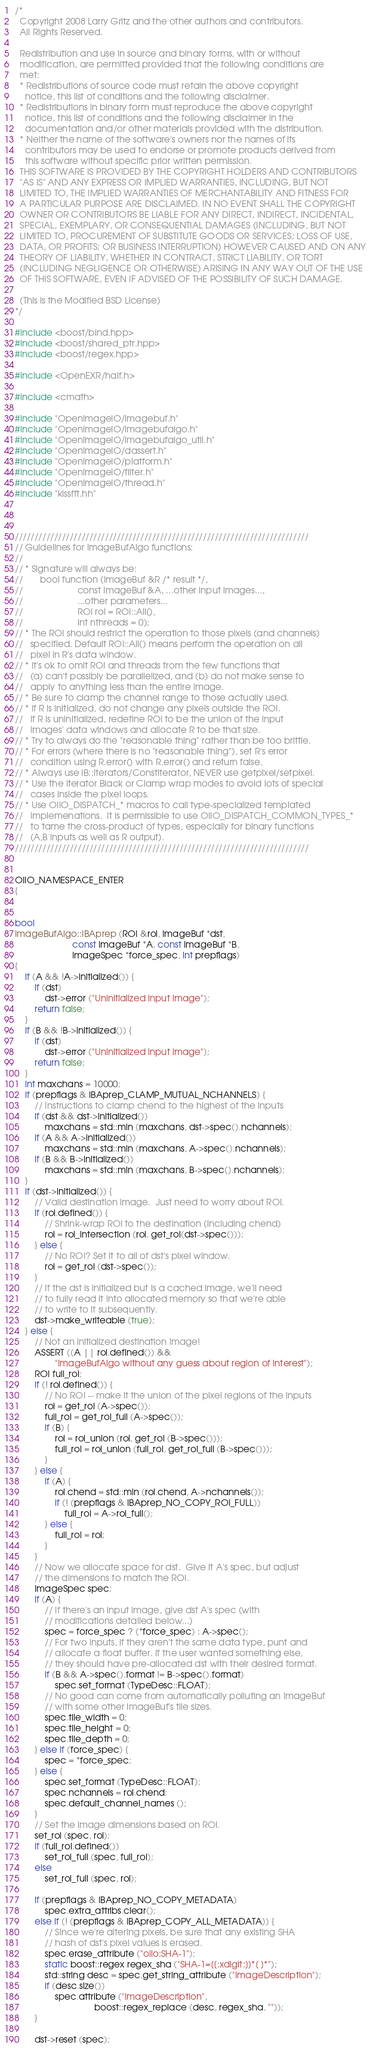Convert code to text. <code><loc_0><loc_0><loc_500><loc_500><_C++_>/*
  Copyright 2008 Larry Gritz and the other authors and contributors.
  All Rights Reserved.

  Redistribution and use in source and binary forms, with or without
  modification, are permitted provided that the following conditions are
  met:
  * Redistributions of source code must retain the above copyright
    notice, this list of conditions and the following disclaimer.
  * Redistributions in binary form must reproduce the above copyright
    notice, this list of conditions and the following disclaimer in the
    documentation and/or other materials provided with the distribution.
  * Neither the name of the software's owners nor the names of its
    contributors may be used to endorse or promote products derived from
    this software without specific prior written permission.
  THIS SOFTWARE IS PROVIDED BY THE COPYRIGHT HOLDERS AND CONTRIBUTORS
  "AS IS" AND ANY EXPRESS OR IMPLIED WARRANTIES, INCLUDING, BUT NOT
  LIMITED TO, THE IMPLIED WARRANTIES OF MERCHANTABILITY AND FITNESS FOR
  A PARTICULAR PURPOSE ARE DISCLAIMED. IN NO EVENT SHALL THE COPYRIGHT
  OWNER OR CONTRIBUTORS BE LIABLE FOR ANY DIRECT, INDIRECT, INCIDENTAL,
  SPECIAL, EXEMPLARY, OR CONSEQUENTIAL DAMAGES (INCLUDING, BUT NOT
  LIMITED TO, PROCUREMENT OF SUBSTITUTE GOODS OR SERVICES; LOSS OF USE,
  DATA, OR PROFITS; OR BUSINESS INTERRUPTION) HOWEVER CAUSED AND ON ANY
  THEORY OF LIABILITY, WHETHER IN CONTRACT, STRICT LIABILITY, OR TORT
  (INCLUDING NEGLIGENCE OR OTHERWISE) ARISING IN ANY WAY OUT OF THE USE
  OF THIS SOFTWARE, EVEN IF ADVISED OF THE POSSIBILITY OF SUCH DAMAGE.

  (This is the Modified BSD License)
*/

#include <boost/bind.hpp>
#include <boost/shared_ptr.hpp>
#include <boost/regex.hpp>

#include <OpenEXR/half.h>

#include <cmath>

#include "OpenImageIO/imagebuf.h"
#include "OpenImageIO/imagebufalgo.h"
#include "OpenImageIO/imagebufalgo_util.h"
#include "OpenImageIO/dassert.h"
#include "OpenImageIO/platform.h"
#include "OpenImageIO/filter.h"
#include "OpenImageIO/thread.h"
#include "kissfft.hh"



///////////////////////////////////////////////////////////////////////////
// Guidelines for ImageBufAlgo functions:
//
// * Signature will always be:
//       bool function (ImageBuf &R /* result */, 
//                      const ImageBuf &A, ...other input images...,
//                      ...other parameters...
//                      ROI roi = ROI::All(),
//                      int nthreads = 0);
// * The ROI should restrict the operation to those pixels (and channels)
//   specified. Default ROI::All() means perform the operation on all
//   pixel in R's data window.
// * It's ok to omit ROI and threads from the few functions that
//   (a) can't possibly be parallelized, and (b) do not make sense to
//   apply to anything less than the entire image.
// * Be sure to clamp the channel range to those actually used.
// * If R is initialized, do not change any pixels outside the ROI.
//   If R is uninitialized, redefine ROI to be the union of the input
//   images' data windows and allocate R to be that size.
// * Try to always do the "reasonable thing" rather than be too brittle.
// * For errors (where there is no "reasonable thing"), set R's error
//   condition using R.error() with R.error() and return false.
// * Always use IB::Iterators/ConstIterator, NEVER use getpixel/setpixel.
// * Use the iterator Black or Clamp wrap modes to avoid lots of special
//   cases inside the pixel loops.
// * Use OIIO_DISPATCH_* macros to call type-specialized templated
//   implemenations.  It is permissible to use OIIO_DISPATCH_COMMON_TYPES_*
//   to tame the cross-product of types, especially for binary functions
//   (A,B inputs as well as R output).
///////////////////////////////////////////////////////////////////////////


OIIO_NAMESPACE_ENTER
{


bool
ImageBufAlgo::IBAprep (ROI &roi, ImageBuf *dst,
                       const ImageBuf *A, const ImageBuf *B,
                       ImageSpec *force_spec, int prepflags)
{
    if (A && !A->initialized()) {
        if (dst)
            dst->error ("Uninitialized input image");
        return false;
    }
    if (B && !B->initialized()) {
        if (dst)
            dst->error ("Uninitialized input image");
        return false;
    }
    int maxchans = 10000;
    if (prepflags & IBAprep_CLAMP_MUTUAL_NCHANNELS) {
        // Instructions to clamp chend to the highest of the inputs
        if (dst && dst->initialized())
            maxchans = std::min (maxchans, dst->spec().nchannels);
        if (A && A->initialized())
            maxchans = std::min (maxchans, A->spec().nchannels);
        if (B && B->initialized())
            maxchans = std::min (maxchans, B->spec().nchannels);
    }
    if (dst->initialized()) {
        // Valid destination image.  Just need to worry about ROI.
        if (roi.defined()) {
            // Shrink-wrap ROI to the destination (including chend)
            roi = roi_intersection (roi, get_roi(dst->spec()));
        } else {
            // No ROI? Set it to all of dst's pixel window.
            roi = get_roi (dst->spec());
        }
        // If the dst is initialized but is a cached image, we'll need
        // to fully read it into allocated memory so that we're able
        // to write to it subsequently.
        dst->make_writeable (true);
    } else {
        // Not an initialized destination image!
        ASSERT ((A || roi.defined()) &&
                "ImageBufAlgo without any guess about region of interest");
        ROI full_roi;
        if (! roi.defined()) {
            // No ROI -- make it the union of the pixel regions of the inputs
            roi = get_roi (A->spec());
            full_roi = get_roi_full (A->spec());
            if (B) {
                roi = roi_union (roi, get_roi (B->spec()));
                full_roi = roi_union (full_roi, get_roi_full (B->spec()));
            }
        } else {
            if (A) {
                roi.chend = std::min (roi.chend, A->nchannels());
                if (! (prepflags & IBAprep_NO_COPY_ROI_FULL))
                    full_roi = A->roi_full();
            } else {
                full_roi = roi;
            }
        }
        // Now we allocate space for dst.  Give it A's spec, but adjust
        // the dimensions to match the ROI.
        ImageSpec spec;
        if (A) {
            // If there's an input image, give dst A's spec (with
            // modifications detailed below...)
            spec = force_spec ? (*force_spec) : A->spec();
            // For two inputs, if they aren't the same data type, punt and
            // allocate a float buffer. If the user wanted something else,
            // they should have pre-allocated dst with their desired format.
            if (B && A->spec().format != B->spec().format)
                spec.set_format (TypeDesc::FLOAT);
            // No good can come from automatically polluting an ImageBuf
            // with some other ImageBuf's tile sizes.
            spec.tile_width = 0;
            spec.tile_height = 0;
            spec.tile_depth = 0;
        } else if (force_spec) {
            spec = *force_spec;
        } else {
            spec.set_format (TypeDesc::FLOAT);
            spec.nchannels = roi.chend;
            spec.default_channel_names ();
        }
        // Set the image dimensions based on ROI.
        set_roi (spec, roi);
        if (full_roi.defined())
            set_roi_full (spec, full_roi);
        else
            set_roi_full (spec, roi);

        if (prepflags & IBAprep_NO_COPY_METADATA)
            spec.extra_attribs.clear();
        else if (! (prepflags & IBAprep_COPY_ALL_METADATA)) {
            // Since we're altering pixels, be sure that any existing SHA
            // hash of dst's pixel values is erased.
            spec.erase_attribute ("oiio:SHA-1");
            static boost::regex regex_sha ("SHA-1=[[:xdigit:]]*[ ]*");
            std::string desc = spec.get_string_attribute ("ImageDescription");
            if (desc.size())
                spec.attribute ("ImageDescription",
                                boost::regex_replace (desc, regex_sha, ""));
        }

        dst->reset (spec);</code> 